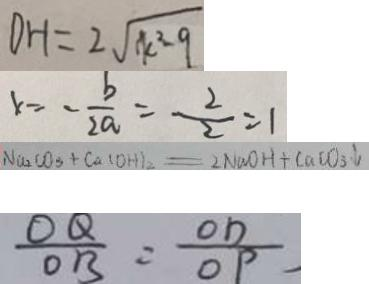<formula> <loc_0><loc_0><loc_500><loc_500>D H = 2 \sqrt { k ^ { 2 } - 9 } 
 x = - \frac { b } { 2 a } = \frac { 2 } { 2 } = 1 
 N a _ { 2 } C O _ { 3 } + C a ( O H ) _ { 2 } = 2 N a O H + C a C O _ { 3 } \downarrow 
 \frac { O Q } { O B } = \frac { O D } { O P }</formula> 